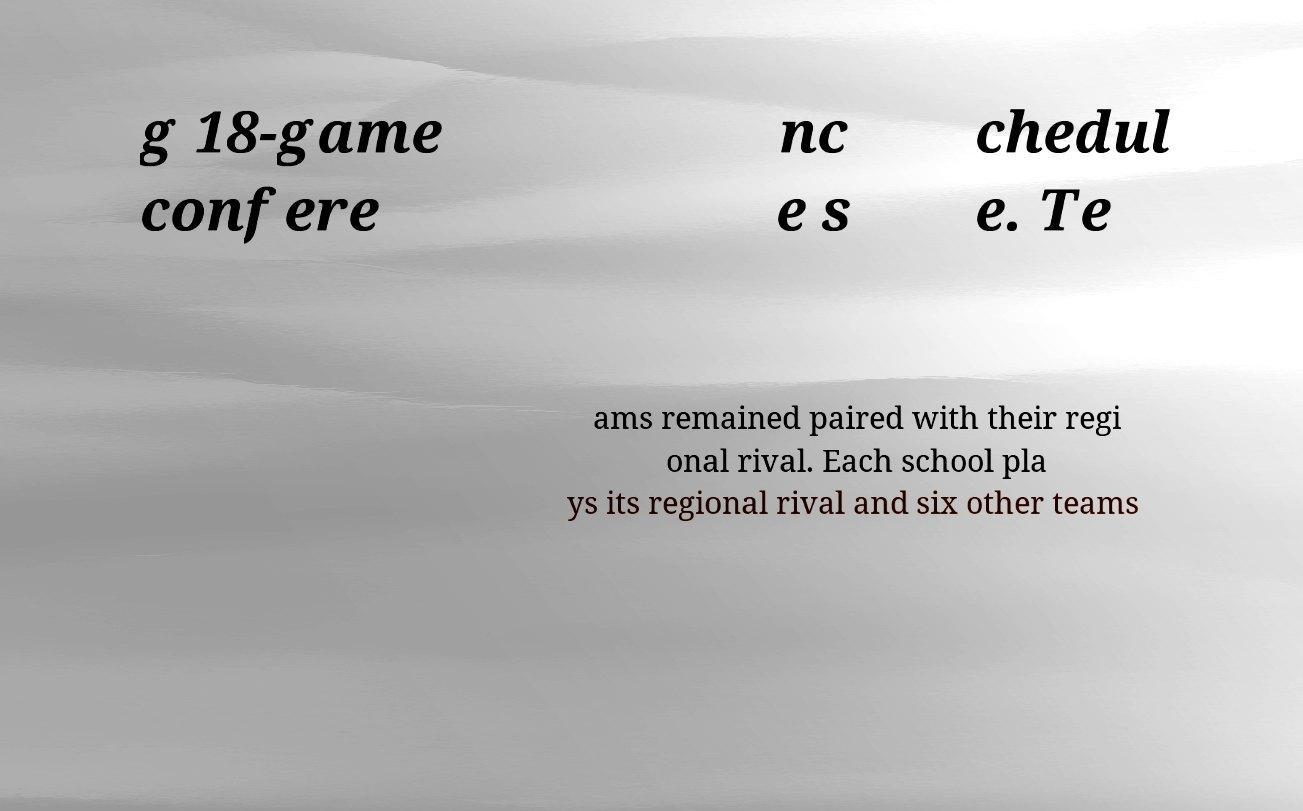There's text embedded in this image that I need extracted. Can you transcribe it verbatim? g 18-game confere nc e s chedul e. Te ams remained paired with their regi onal rival. Each school pla ys its regional rival and six other teams 